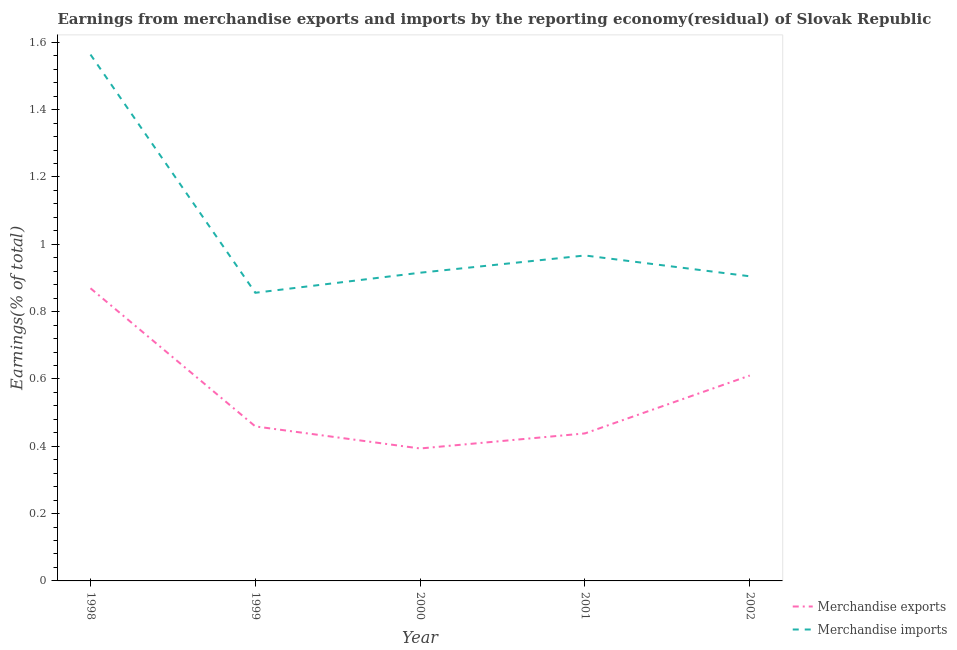How many different coloured lines are there?
Offer a terse response. 2. Does the line corresponding to earnings from merchandise exports intersect with the line corresponding to earnings from merchandise imports?
Offer a very short reply. No. Is the number of lines equal to the number of legend labels?
Ensure brevity in your answer.  Yes. What is the earnings from merchandise exports in 1999?
Offer a terse response. 0.46. Across all years, what is the maximum earnings from merchandise exports?
Ensure brevity in your answer.  0.87. Across all years, what is the minimum earnings from merchandise exports?
Your answer should be compact. 0.39. In which year was the earnings from merchandise exports maximum?
Make the answer very short. 1998. What is the total earnings from merchandise exports in the graph?
Your answer should be very brief. 2.77. What is the difference between the earnings from merchandise imports in 2001 and that in 2002?
Keep it short and to the point. 0.06. What is the difference between the earnings from merchandise imports in 1998 and the earnings from merchandise exports in 2001?
Provide a succinct answer. 1.13. What is the average earnings from merchandise exports per year?
Provide a succinct answer. 0.55. In the year 1998, what is the difference between the earnings from merchandise imports and earnings from merchandise exports?
Your answer should be compact. 0.69. What is the ratio of the earnings from merchandise imports in 2001 to that in 2002?
Your response must be concise. 1.07. Is the earnings from merchandise imports in 2001 less than that in 2002?
Your answer should be compact. No. What is the difference between the highest and the second highest earnings from merchandise imports?
Provide a short and direct response. 0.6. What is the difference between the highest and the lowest earnings from merchandise imports?
Offer a very short reply. 0.71. In how many years, is the earnings from merchandise exports greater than the average earnings from merchandise exports taken over all years?
Make the answer very short. 2. Is the sum of the earnings from merchandise exports in 1999 and 2000 greater than the maximum earnings from merchandise imports across all years?
Make the answer very short. No. Does the earnings from merchandise imports monotonically increase over the years?
Offer a very short reply. No. Is the earnings from merchandise imports strictly less than the earnings from merchandise exports over the years?
Ensure brevity in your answer.  No. How many lines are there?
Make the answer very short. 2. How many years are there in the graph?
Your response must be concise. 5. How are the legend labels stacked?
Offer a very short reply. Vertical. What is the title of the graph?
Your answer should be compact. Earnings from merchandise exports and imports by the reporting economy(residual) of Slovak Republic. What is the label or title of the X-axis?
Your answer should be very brief. Year. What is the label or title of the Y-axis?
Your response must be concise. Earnings(% of total). What is the Earnings(% of total) of Merchandise exports in 1998?
Ensure brevity in your answer.  0.87. What is the Earnings(% of total) in Merchandise imports in 1998?
Your answer should be very brief. 1.56. What is the Earnings(% of total) of Merchandise exports in 1999?
Ensure brevity in your answer.  0.46. What is the Earnings(% of total) in Merchandise imports in 1999?
Offer a very short reply. 0.86. What is the Earnings(% of total) in Merchandise exports in 2000?
Your response must be concise. 0.39. What is the Earnings(% of total) in Merchandise imports in 2000?
Keep it short and to the point. 0.92. What is the Earnings(% of total) of Merchandise exports in 2001?
Offer a very short reply. 0.44. What is the Earnings(% of total) of Merchandise imports in 2001?
Your response must be concise. 0.97. What is the Earnings(% of total) of Merchandise exports in 2002?
Ensure brevity in your answer.  0.61. What is the Earnings(% of total) in Merchandise imports in 2002?
Make the answer very short. 0.9. Across all years, what is the maximum Earnings(% of total) in Merchandise exports?
Give a very brief answer. 0.87. Across all years, what is the maximum Earnings(% of total) of Merchandise imports?
Your answer should be very brief. 1.56. Across all years, what is the minimum Earnings(% of total) in Merchandise exports?
Your response must be concise. 0.39. Across all years, what is the minimum Earnings(% of total) of Merchandise imports?
Your answer should be compact. 0.86. What is the total Earnings(% of total) of Merchandise exports in the graph?
Provide a short and direct response. 2.77. What is the total Earnings(% of total) of Merchandise imports in the graph?
Your answer should be compact. 5.21. What is the difference between the Earnings(% of total) of Merchandise exports in 1998 and that in 1999?
Your answer should be compact. 0.41. What is the difference between the Earnings(% of total) of Merchandise imports in 1998 and that in 1999?
Ensure brevity in your answer.  0.71. What is the difference between the Earnings(% of total) of Merchandise exports in 1998 and that in 2000?
Keep it short and to the point. 0.48. What is the difference between the Earnings(% of total) in Merchandise imports in 1998 and that in 2000?
Offer a very short reply. 0.65. What is the difference between the Earnings(% of total) of Merchandise exports in 1998 and that in 2001?
Your answer should be very brief. 0.43. What is the difference between the Earnings(% of total) of Merchandise imports in 1998 and that in 2001?
Offer a very short reply. 0.6. What is the difference between the Earnings(% of total) in Merchandise exports in 1998 and that in 2002?
Make the answer very short. 0.26. What is the difference between the Earnings(% of total) of Merchandise imports in 1998 and that in 2002?
Ensure brevity in your answer.  0.66. What is the difference between the Earnings(% of total) of Merchandise exports in 1999 and that in 2000?
Keep it short and to the point. 0.07. What is the difference between the Earnings(% of total) in Merchandise imports in 1999 and that in 2000?
Ensure brevity in your answer.  -0.06. What is the difference between the Earnings(% of total) of Merchandise exports in 1999 and that in 2001?
Your answer should be very brief. 0.02. What is the difference between the Earnings(% of total) in Merchandise imports in 1999 and that in 2001?
Make the answer very short. -0.11. What is the difference between the Earnings(% of total) of Merchandise exports in 1999 and that in 2002?
Your response must be concise. -0.15. What is the difference between the Earnings(% of total) in Merchandise imports in 1999 and that in 2002?
Offer a terse response. -0.05. What is the difference between the Earnings(% of total) of Merchandise exports in 2000 and that in 2001?
Offer a very short reply. -0.04. What is the difference between the Earnings(% of total) in Merchandise imports in 2000 and that in 2001?
Offer a terse response. -0.05. What is the difference between the Earnings(% of total) of Merchandise exports in 2000 and that in 2002?
Provide a short and direct response. -0.22. What is the difference between the Earnings(% of total) of Merchandise imports in 2000 and that in 2002?
Your answer should be very brief. 0.01. What is the difference between the Earnings(% of total) in Merchandise exports in 2001 and that in 2002?
Provide a short and direct response. -0.17. What is the difference between the Earnings(% of total) in Merchandise imports in 2001 and that in 2002?
Your answer should be very brief. 0.06. What is the difference between the Earnings(% of total) of Merchandise exports in 1998 and the Earnings(% of total) of Merchandise imports in 1999?
Keep it short and to the point. 0.01. What is the difference between the Earnings(% of total) of Merchandise exports in 1998 and the Earnings(% of total) of Merchandise imports in 2000?
Offer a very short reply. -0.05. What is the difference between the Earnings(% of total) in Merchandise exports in 1998 and the Earnings(% of total) in Merchandise imports in 2001?
Provide a succinct answer. -0.1. What is the difference between the Earnings(% of total) in Merchandise exports in 1998 and the Earnings(% of total) in Merchandise imports in 2002?
Keep it short and to the point. -0.04. What is the difference between the Earnings(% of total) in Merchandise exports in 1999 and the Earnings(% of total) in Merchandise imports in 2000?
Keep it short and to the point. -0.46. What is the difference between the Earnings(% of total) of Merchandise exports in 1999 and the Earnings(% of total) of Merchandise imports in 2001?
Offer a terse response. -0.51. What is the difference between the Earnings(% of total) of Merchandise exports in 1999 and the Earnings(% of total) of Merchandise imports in 2002?
Provide a succinct answer. -0.45. What is the difference between the Earnings(% of total) of Merchandise exports in 2000 and the Earnings(% of total) of Merchandise imports in 2001?
Give a very brief answer. -0.57. What is the difference between the Earnings(% of total) in Merchandise exports in 2000 and the Earnings(% of total) in Merchandise imports in 2002?
Offer a terse response. -0.51. What is the difference between the Earnings(% of total) in Merchandise exports in 2001 and the Earnings(% of total) in Merchandise imports in 2002?
Give a very brief answer. -0.47. What is the average Earnings(% of total) of Merchandise exports per year?
Offer a terse response. 0.55. What is the average Earnings(% of total) in Merchandise imports per year?
Make the answer very short. 1.04. In the year 1998, what is the difference between the Earnings(% of total) in Merchandise exports and Earnings(% of total) in Merchandise imports?
Provide a short and direct response. -0.69. In the year 1999, what is the difference between the Earnings(% of total) of Merchandise exports and Earnings(% of total) of Merchandise imports?
Provide a succinct answer. -0.4. In the year 2000, what is the difference between the Earnings(% of total) in Merchandise exports and Earnings(% of total) in Merchandise imports?
Your answer should be compact. -0.52. In the year 2001, what is the difference between the Earnings(% of total) of Merchandise exports and Earnings(% of total) of Merchandise imports?
Offer a very short reply. -0.53. In the year 2002, what is the difference between the Earnings(% of total) in Merchandise exports and Earnings(% of total) in Merchandise imports?
Give a very brief answer. -0.29. What is the ratio of the Earnings(% of total) of Merchandise exports in 1998 to that in 1999?
Your answer should be very brief. 1.89. What is the ratio of the Earnings(% of total) in Merchandise imports in 1998 to that in 1999?
Keep it short and to the point. 1.83. What is the ratio of the Earnings(% of total) in Merchandise exports in 1998 to that in 2000?
Make the answer very short. 2.21. What is the ratio of the Earnings(% of total) of Merchandise imports in 1998 to that in 2000?
Make the answer very short. 1.71. What is the ratio of the Earnings(% of total) in Merchandise exports in 1998 to that in 2001?
Ensure brevity in your answer.  1.98. What is the ratio of the Earnings(% of total) of Merchandise imports in 1998 to that in 2001?
Ensure brevity in your answer.  1.62. What is the ratio of the Earnings(% of total) in Merchandise exports in 1998 to that in 2002?
Your answer should be compact. 1.42. What is the ratio of the Earnings(% of total) in Merchandise imports in 1998 to that in 2002?
Your answer should be compact. 1.73. What is the ratio of the Earnings(% of total) of Merchandise exports in 1999 to that in 2000?
Provide a succinct answer. 1.17. What is the ratio of the Earnings(% of total) of Merchandise imports in 1999 to that in 2000?
Offer a terse response. 0.93. What is the ratio of the Earnings(% of total) of Merchandise exports in 1999 to that in 2001?
Your response must be concise. 1.05. What is the ratio of the Earnings(% of total) in Merchandise imports in 1999 to that in 2001?
Keep it short and to the point. 0.89. What is the ratio of the Earnings(% of total) in Merchandise exports in 1999 to that in 2002?
Your answer should be very brief. 0.75. What is the ratio of the Earnings(% of total) of Merchandise imports in 1999 to that in 2002?
Your answer should be compact. 0.95. What is the ratio of the Earnings(% of total) of Merchandise exports in 2000 to that in 2001?
Give a very brief answer. 0.9. What is the ratio of the Earnings(% of total) in Merchandise imports in 2000 to that in 2001?
Offer a terse response. 0.95. What is the ratio of the Earnings(% of total) in Merchandise exports in 2000 to that in 2002?
Make the answer very short. 0.64. What is the ratio of the Earnings(% of total) of Merchandise imports in 2000 to that in 2002?
Provide a short and direct response. 1.01. What is the ratio of the Earnings(% of total) of Merchandise exports in 2001 to that in 2002?
Provide a short and direct response. 0.72. What is the ratio of the Earnings(% of total) of Merchandise imports in 2001 to that in 2002?
Ensure brevity in your answer.  1.07. What is the difference between the highest and the second highest Earnings(% of total) in Merchandise exports?
Ensure brevity in your answer.  0.26. What is the difference between the highest and the second highest Earnings(% of total) in Merchandise imports?
Give a very brief answer. 0.6. What is the difference between the highest and the lowest Earnings(% of total) of Merchandise exports?
Your response must be concise. 0.48. What is the difference between the highest and the lowest Earnings(% of total) of Merchandise imports?
Offer a terse response. 0.71. 